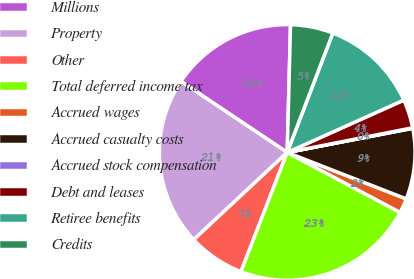Convert chart to OTSL. <chart><loc_0><loc_0><loc_500><loc_500><pie_chart><fcel>Millions<fcel>Property<fcel>Other<fcel>Total deferred income tax<fcel>Accrued wages<fcel>Accrued casualty costs<fcel>Accrued stock compensation<fcel>Debt and leases<fcel>Retiree benefits<fcel>Credits<nl><fcel>16.03%<fcel>21.34%<fcel>7.16%<fcel>23.12%<fcel>1.85%<fcel>8.94%<fcel>0.07%<fcel>3.62%<fcel>12.48%<fcel>5.39%<nl></chart> 